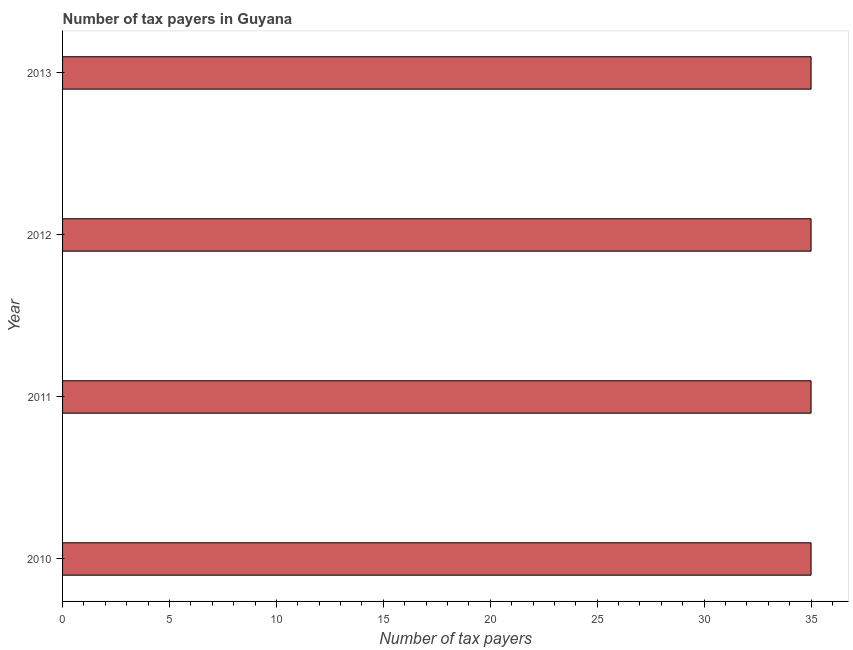Does the graph contain any zero values?
Provide a short and direct response. No. Does the graph contain grids?
Provide a short and direct response. No. What is the title of the graph?
Provide a succinct answer. Number of tax payers in Guyana. What is the label or title of the X-axis?
Offer a very short reply. Number of tax payers. What is the label or title of the Y-axis?
Your answer should be very brief. Year. What is the number of tax payers in 2012?
Keep it short and to the point. 35. In which year was the number of tax payers maximum?
Provide a succinct answer. 2010. What is the sum of the number of tax payers?
Your answer should be very brief. 140. What is the average number of tax payers per year?
Make the answer very short. 35. What is the ratio of the number of tax payers in 2010 to that in 2011?
Provide a succinct answer. 1. Is the number of tax payers in 2011 less than that in 2013?
Offer a very short reply. No. Is the difference between the number of tax payers in 2011 and 2013 greater than the difference between any two years?
Your answer should be compact. Yes. What is the difference between the highest and the lowest number of tax payers?
Offer a terse response. 0. In how many years, is the number of tax payers greater than the average number of tax payers taken over all years?
Provide a succinct answer. 0. What is the difference between two consecutive major ticks on the X-axis?
Your answer should be compact. 5. What is the Number of tax payers in 2010?
Your answer should be compact. 35. What is the difference between the Number of tax payers in 2010 and 2011?
Keep it short and to the point. 0. What is the difference between the Number of tax payers in 2010 and 2012?
Ensure brevity in your answer.  0. What is the difference between the Number of tax payers in 2010 and 2013?
Your answer should be very brief. 0. What is the difference between the Number of tax payers in 2011 and 2013?
Provide a succinct answer. 0. What is the difference between the Number of tax payers in 2012 and 2013?
Provide a succinct answer. 0. What is the ratio of the Number of tax payers in 2010 to that in 2011?
Your response must be concise. 1. What is the ratio of the Number of tax payers in 2010 to that in 2012?
Make the answer very short. 1. What is the ratio of the Number of tax payers in 2010 to that in 2013?
Your answer should be very brief. 1. What is the ratio of the Number of tax payers in 2011 to that in 2012?
Ensure brevity in your answer.  1. What is the ratio of the Number of tax payers in 2012 to that in 2013?
Your answer should be very brief. 1. 